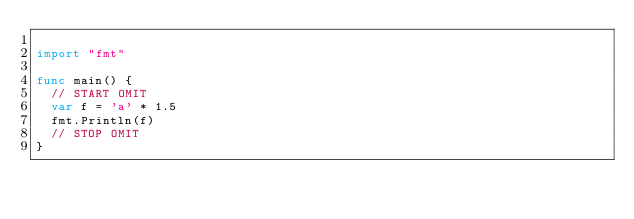<code> <loc_0><loc_0><loc_500><loc_500><_Go_>
import "fmt"

func main() {
	// START OMIT
	var f = 'a' * 1.5
	fmt.Println(f)
	// STOP OMIT
}
</code> 